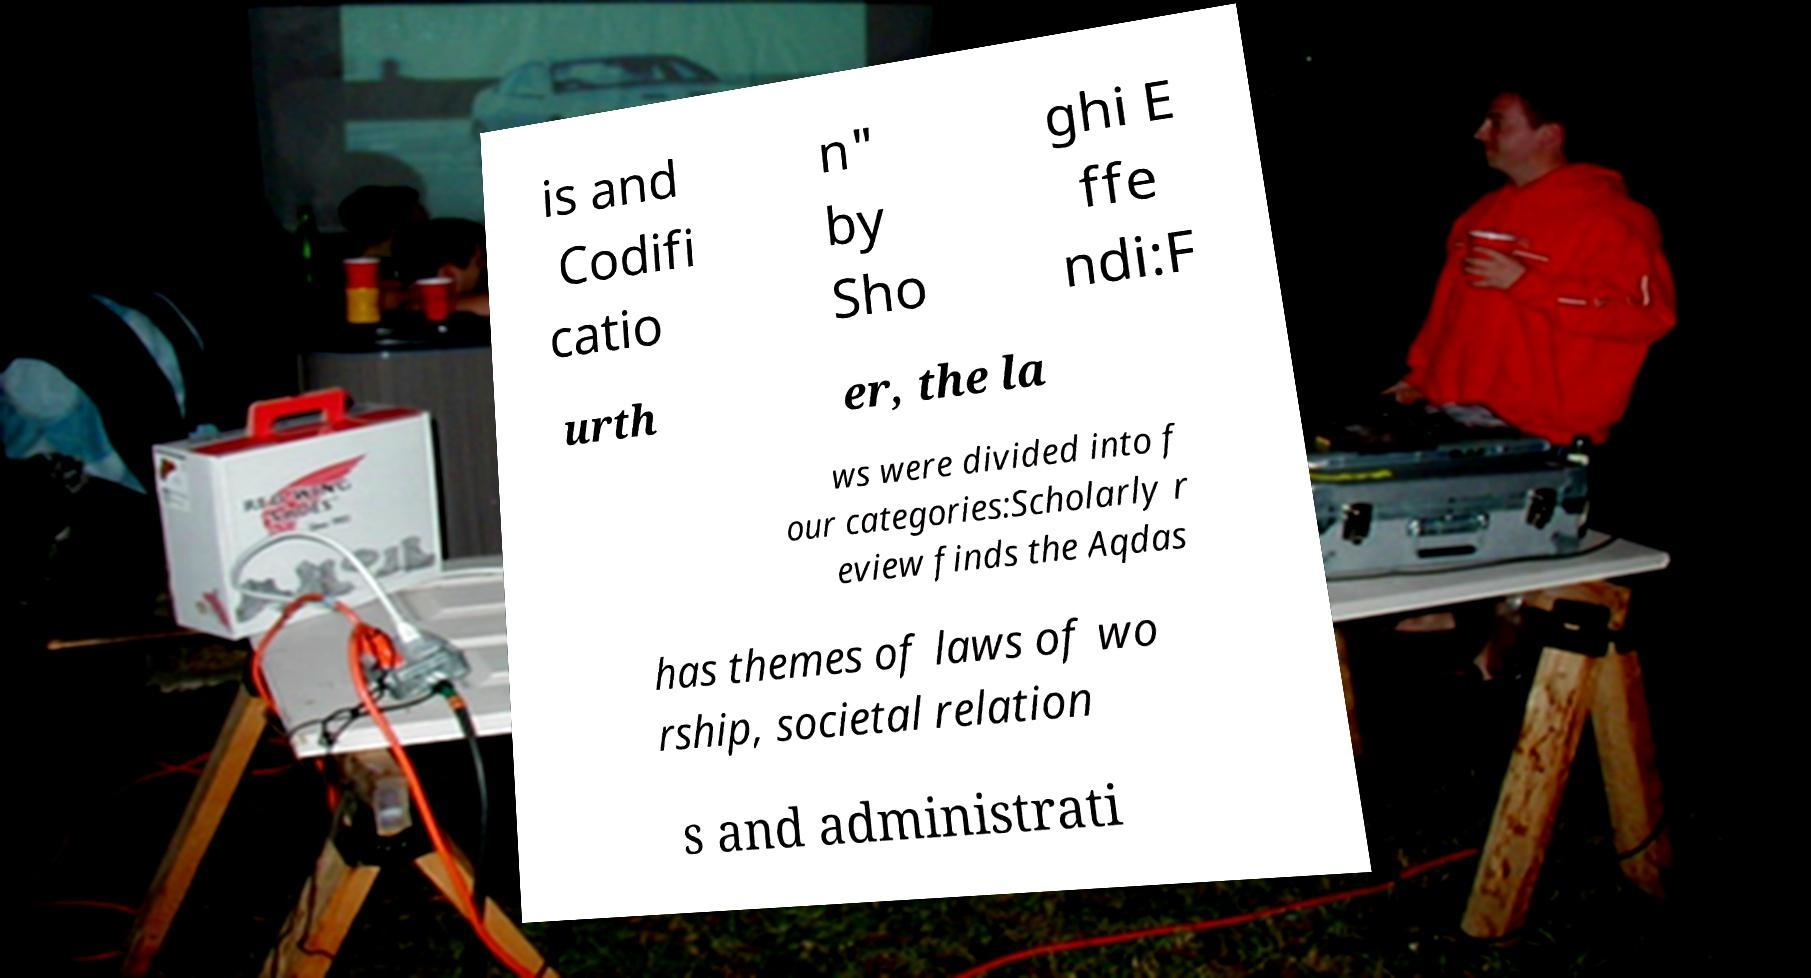For documentation purposes, I need the text within this image transcribed. Could you provide that? is and Codifi catio n" by Sho ghi E ffe ndi:F urth er, the la ws were divided into f our categories:Scholarly r eview finds the Aqdas has themes of laws of wo rship, societal relation s and administrati 